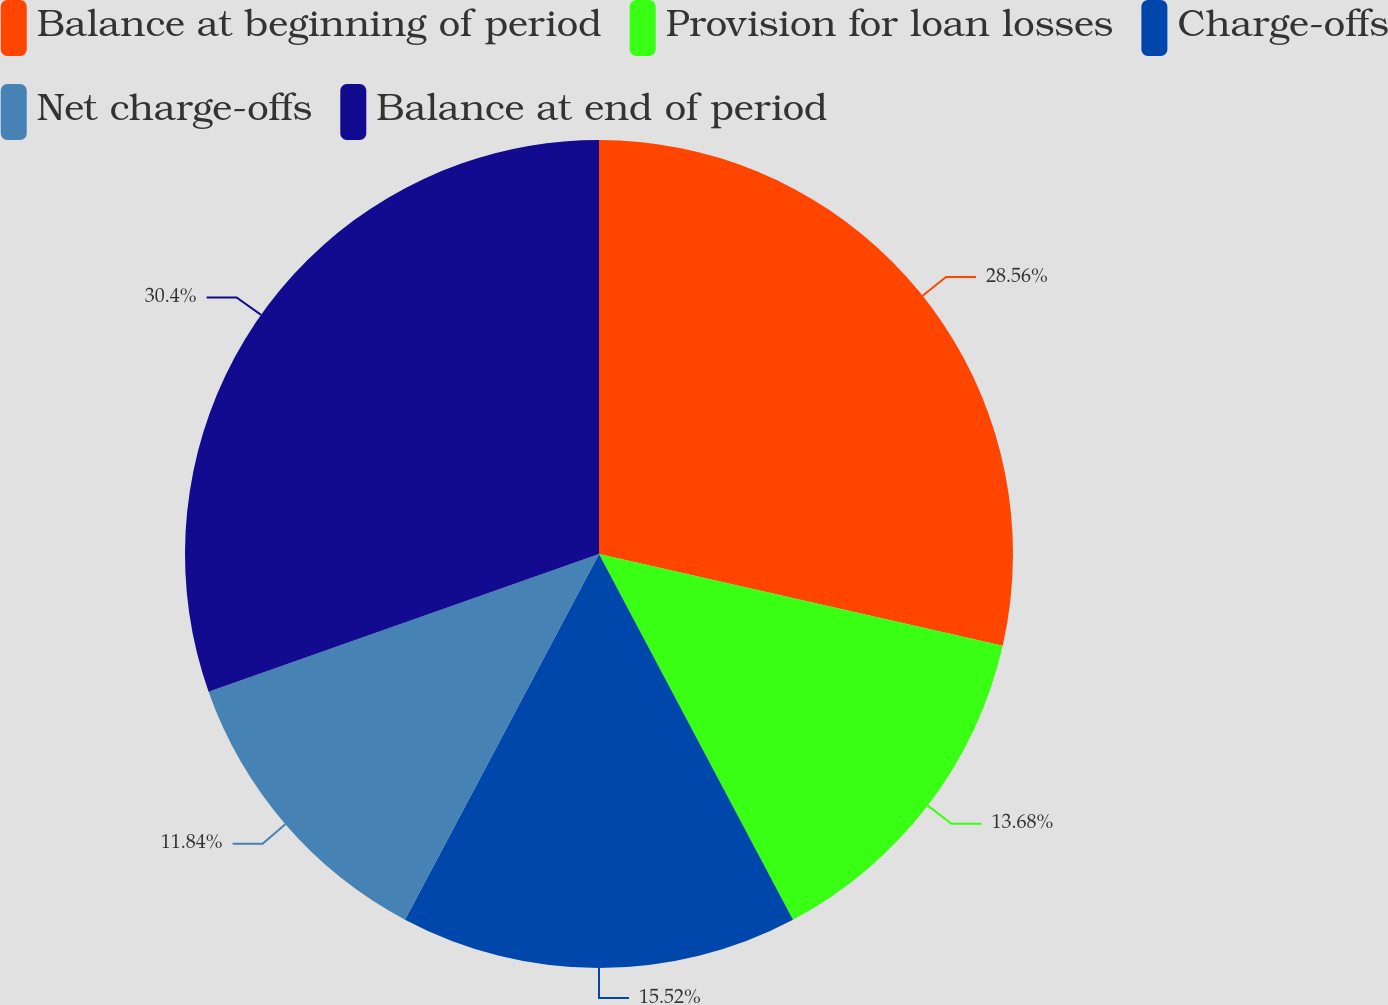<chart> <loc_0><loc_0><loc_500><loc_500><pie_chart><fcel>Balance at beginning of period<fcel>Provision for loan losses<fcel>Charge-offs<fcel>Net charge-offs<fcel>Balance at end of period<nl><fcel>28.55%<fcel>13.68%<fcel>15.52%<fcel>11.84%<fcel>30.39%<nl></chart> 